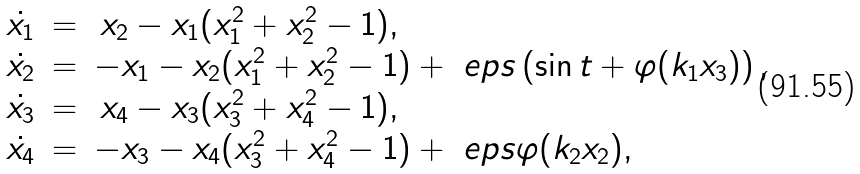<formula> <loc_0><loc_0><loc_500><loc_500>\begin{array} { l l l } \dot { x _ { 1 } } & = & \, x _ { 2 } - x _ { 1 } ( x _ { 1 } ^ { 2 } + x _ { 2 } ^ { 2 } - 1 ) , \\ \dot { x _ { 2 } } & = & - x _ { 1 } - x _ { 2 } ( x _ { 1 } ^ { 2 } + x _ { 2 } ^ { 2 } - 1 ) + \ e p s \left ( \sin t + \varphi ( k _ { 1 } x _ { 3 } ) \right ) , \\ \dot { x _ { 3 } } & = & \, x _ { 4 } - x _ { 3 } ( x _ { 3 } ^ { 2 } + x _ { 4 } ^ { 2 } - 1 ) , \\ \dot { x _ { 4 } } & = & - x _ { 3 } - x _ { 4 } ( x _ { 3 } ^ { 2 } + x _ { 4 } ^ { 2 } - 1 ) + \ e p s \varphi ( k _ { 2 } x _ { 2 } ) , \end{array}</formula> 